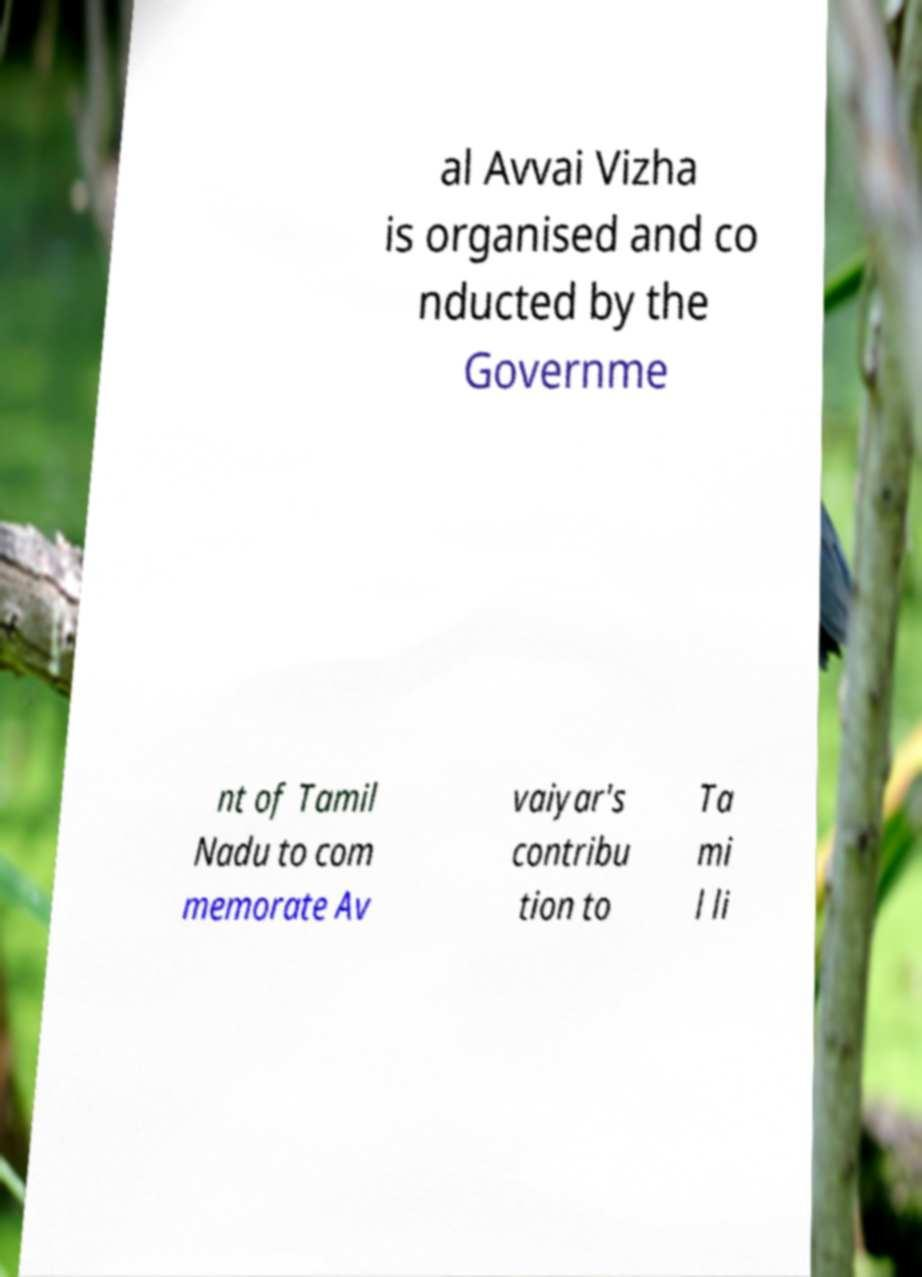Please identify and transcribe the text found in this image. al Avvai Vizha is organised and co nducted by the Governme nt of Tamil Nadu to com memorate Av vaiyar's contribu tion to Ta mi l li 